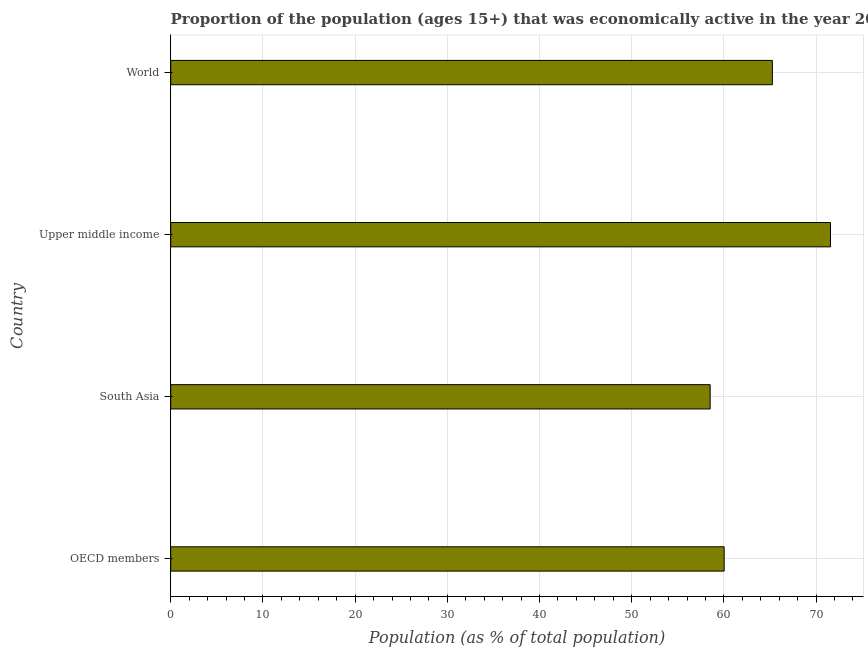Does the graph contain grids?
Your answer should be very brief. Yes. What is the title of the graph?
Ensure brevity in your answer.  Proportion of the population (ages 15+) that was economically active in the year 2001. What is the label or title of the X-axis?
Your response must be concise. Population (as % of total population). What is the label or title of the Y-axis?
Offer a very short reply. Country. What is the percentage of economically active population in World?
Offer a terse response. 65.26. Across all countries, what is the maximum percentage of economically active population?
Your response must be concise. 71.56. Across all countries, what is the minimum percentage of economically active population?
Make the answer very short. 58.51. In which country was the percentage of economically active population maximum?
Ensure brevity in your answer.  Upper middle income. In which country was the percentage of economically active population minimum?
Provide a succinct answer. South Asia. What is the sum of the percentage of economically active population?
Your answer should be compact. 255.35. What is the difference between the percentage of economically active population in South Asia and World?
Your response must be concise. -6.75. What is the average percentage of economically active population per country?
Provide a succinct answer. 63.84. What is the median percentage of economically active population?
Keep it short and to the point. 62.64. In how many countries, is the percentage of economically active population greater than 32 %?
Provide a succinct answer. 4. What is the ratio of the percentage of economically active population in OECD members to that in Upper middle income?
Keep it short and to the point. 0.84. Is the percentage of economically active population in OECD members less than that in Upper middle income?
Make the answer very short. Yes. Is the difference between the percentage of economically active population in South Asia and Upper middle income greater than the difference between any two countries?
Your response must be concise. Yes. What is the difference between the highest and the second highest percentage of economically active population?
Ensure brevity in your answer.  6.31. Is the sum of the percentage of economically active population in South Asia and World greater than the maximum percentage of economically active population across all countries?
Offer a terse response. Yes. What is the difference between the highest and the lowest percentage of economically active population?
Your response must be concise. 13.05. How many bars are there?
Offer a very short reply. 4. How many countries are there in the graph?
Provide a short and direct response. 4. What is the difference between two consecutive major ticks on the X-axis?
Offer a very short reply. 10. Are the values on the major ticks of X-axis written in scientific E-notation?
Make the answer very short. No. What is the Population (as % of total population) in OECD members?
Provide a short and direct response. 60.03. What is the Population (as % of total population) in South Asia?
Offer a very short reply. 58.51. What is the Population (as % of total population) in Upper middle income?
Your answer should be compact. 71.56. What is the Population (as % of total population) in World?
Provide a short and direct response. 65.26. What is the difference between the Population (as % of total population) in OECD members and South Asia?
Your answer should be very brief. 1.52. What is the difference between the Population (as % of total population) in OECD members and Upper middle income?
Give a very brief answer. -11.54. What is the difference between the Population (as % of total population) in OECD members and World?
Ensure brevity in your answer.  -5.23. What is the difference between the Population (as % of total population) in South Asia and Upper middle income?
Offer a terse response. -13.05. What is the difference between the Population (as % of total population) in South Asia and World?
Your answer should be compact. -6.75. What is the difference between the Population (as % of total population) in Upper middle income and World?
Give a very brief answer. 6.31. What is the ratio of the Population (as % of total population) in OECD members to that in South Asia?
Offer a very short reply. 1.03. What is the ratio of the Population (as % of total population) in OECD members to that in Upper middle income?
Ensure brevity in your answer.  0.84. What is the ratio of the Population (as % of total population) in South Asia to that in Upper middle income?
Keep it short and to the point. 0.82. What is the ratio of the Population (as % of total population) in South Asia to that in World?
Make the answer very short. 0.9. What is the ratio of the Population (as % of total population) in Upper middle income to that in World?
Your response must be concise. 1.1. 